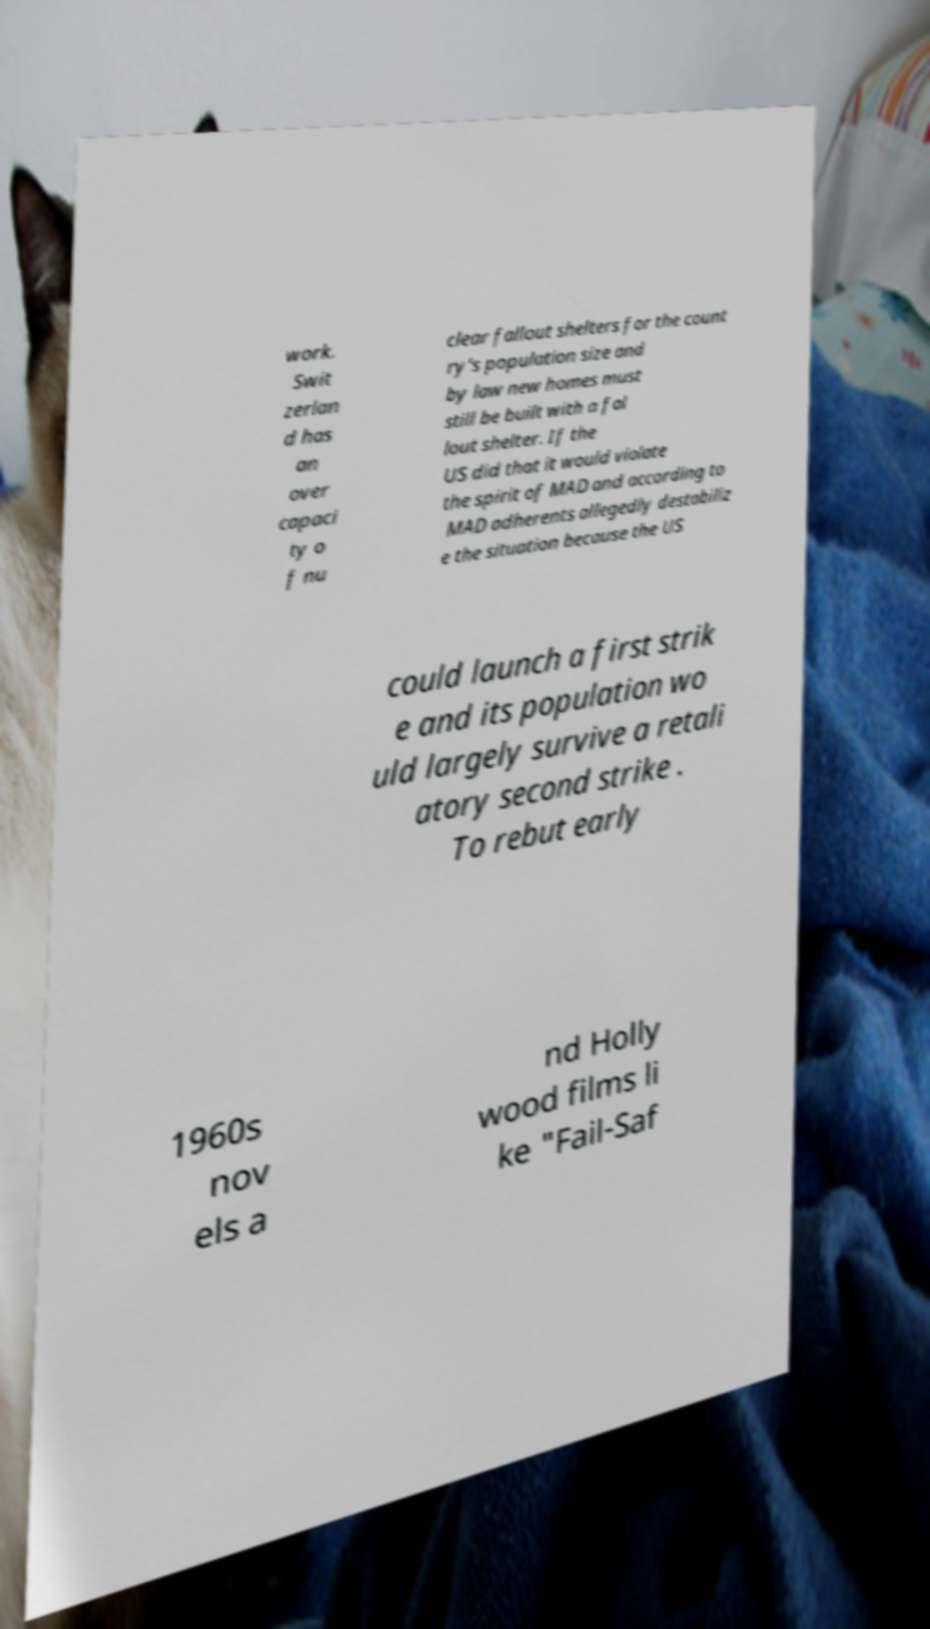Can you accurately transcribe the text from the provided image for me? work. Swit zerlan d has an over capaci ty o f nu clear fallout shelters for the count ry's population size and by law new homes must still be built with a fal lout shelter. If the US did that it would violate the spirit of MAD and according to MAD adherents allegedly destabiliz e the situation because the US could launch a first strik e and its population wo uld largely survive a retali atory second strike . To rebut early 1960s nov els a nd Holly wood films li ke "Fail-Saf 